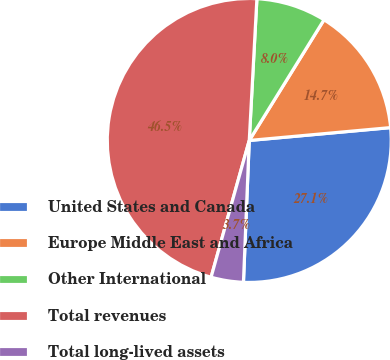<chart> <loc_0><loc_0><loc_500><loc_500><pie_chart><fcel>United States and Canada<fcel>Europe Middle East and Africa<fcel>Other International<fcel>Total revenues<fcel>Total long-lived assets<nl><fcel>27.1%<fcel>14.73%<fcel>7.97%<fcel>46.53%<fcel>3.68%<nl></chart> 